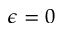<formula> <loc_0><loc_0><loc_500><loc_500>\epsilon = 0</formula> 